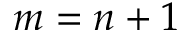Convert formula to latex. <formula><loc_0><loc_0><loc_500><loc_500>m = n + 1</formula> 